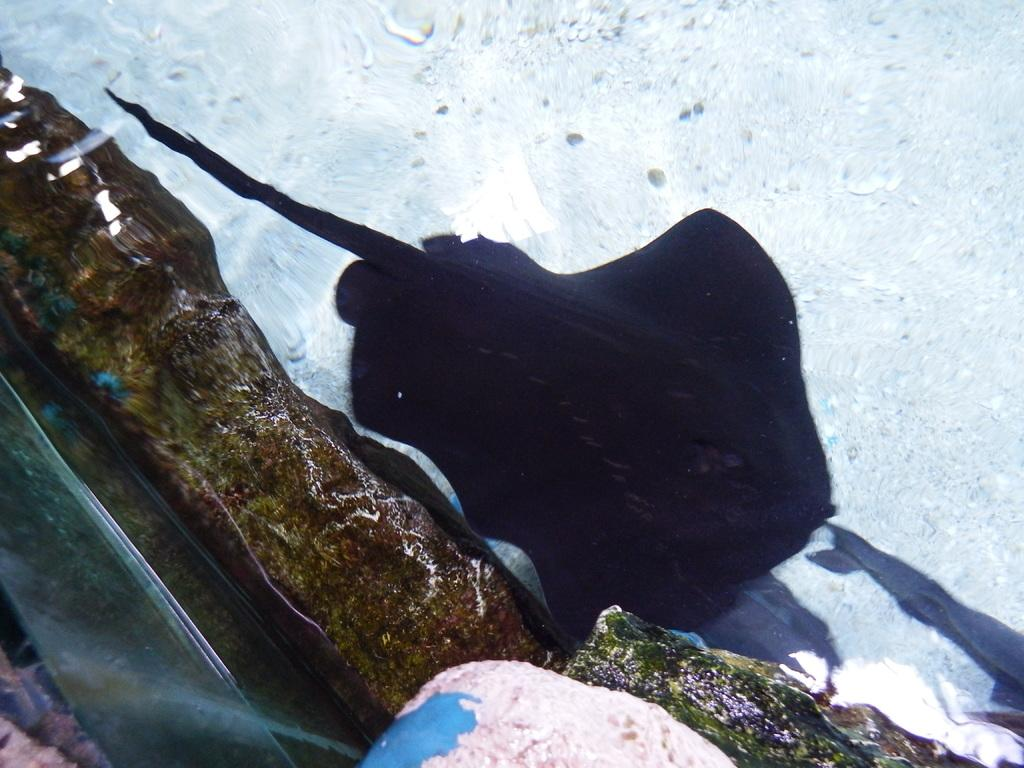What type of animal is in the image? There is a fish in the image. What other object can be seen in the image? There is a rock in the image. Where are the fish and the rock located? Both the fish and the rock are in the water. What type of cherries are floating on the water in the image? There are no cherries present in the image; it features a fish and a rock in the water. 